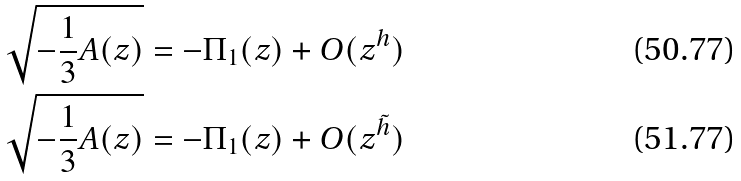Convert formula to latex. <formula><loc_0><loc_0><loc_500><loc_500>& \sqrt { - \frac { 1 } { 3 } A ( z ) } = - \Pi _ { 1 } ( z ) + O ( z ^ { h } ) \\ & \sqrt { - \frac { 1 } { 3 } A ( z ) } = - \Pi _ { 1 } ( z ) + O ( z ^ { \tilde { h } } )</formula> 